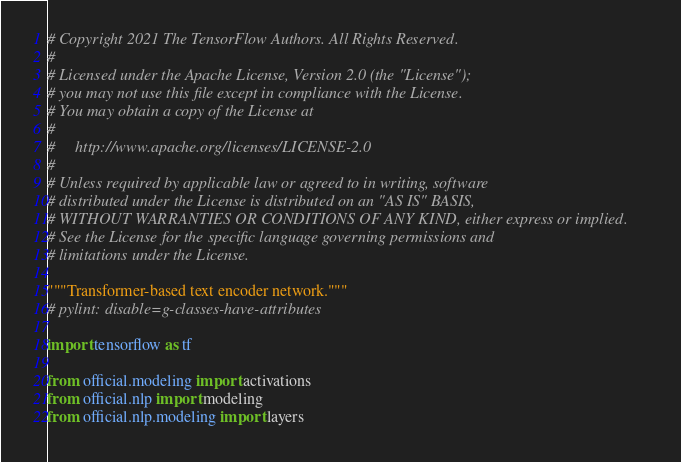Convert code to text. <code><loc_0><loc_0><loc_500><loc_500><_Python_># Copyright 2021 The TensorFlow Authors. All Rights Reserved.
#
# Licensed under the Apache License, Version 2.0 (the "License");
# you may not use this file except in compliance with the License.
# You may obtain a copy of the License at
#
#     http://www.apache.org/licenses/LICENSE-2.0
#
# Unless required by applicable law or agreed to in writing, software
# distributed under the License is distributed on an "AS IS" BASIS,
# WITHOUT WARRANTIES OR CONDITIONS OF ANY KIND, either express or implied.
# See the License for the specific language governing permissions and
# limitations under the License.

"""Transformer-based text encoder network."""
# pylint: disable=g-classes-have-attributes

import tensorflow as tf

from official.modeling import activations
from official.nlp import modeling
from official.nlp.modeling import layers</code> 